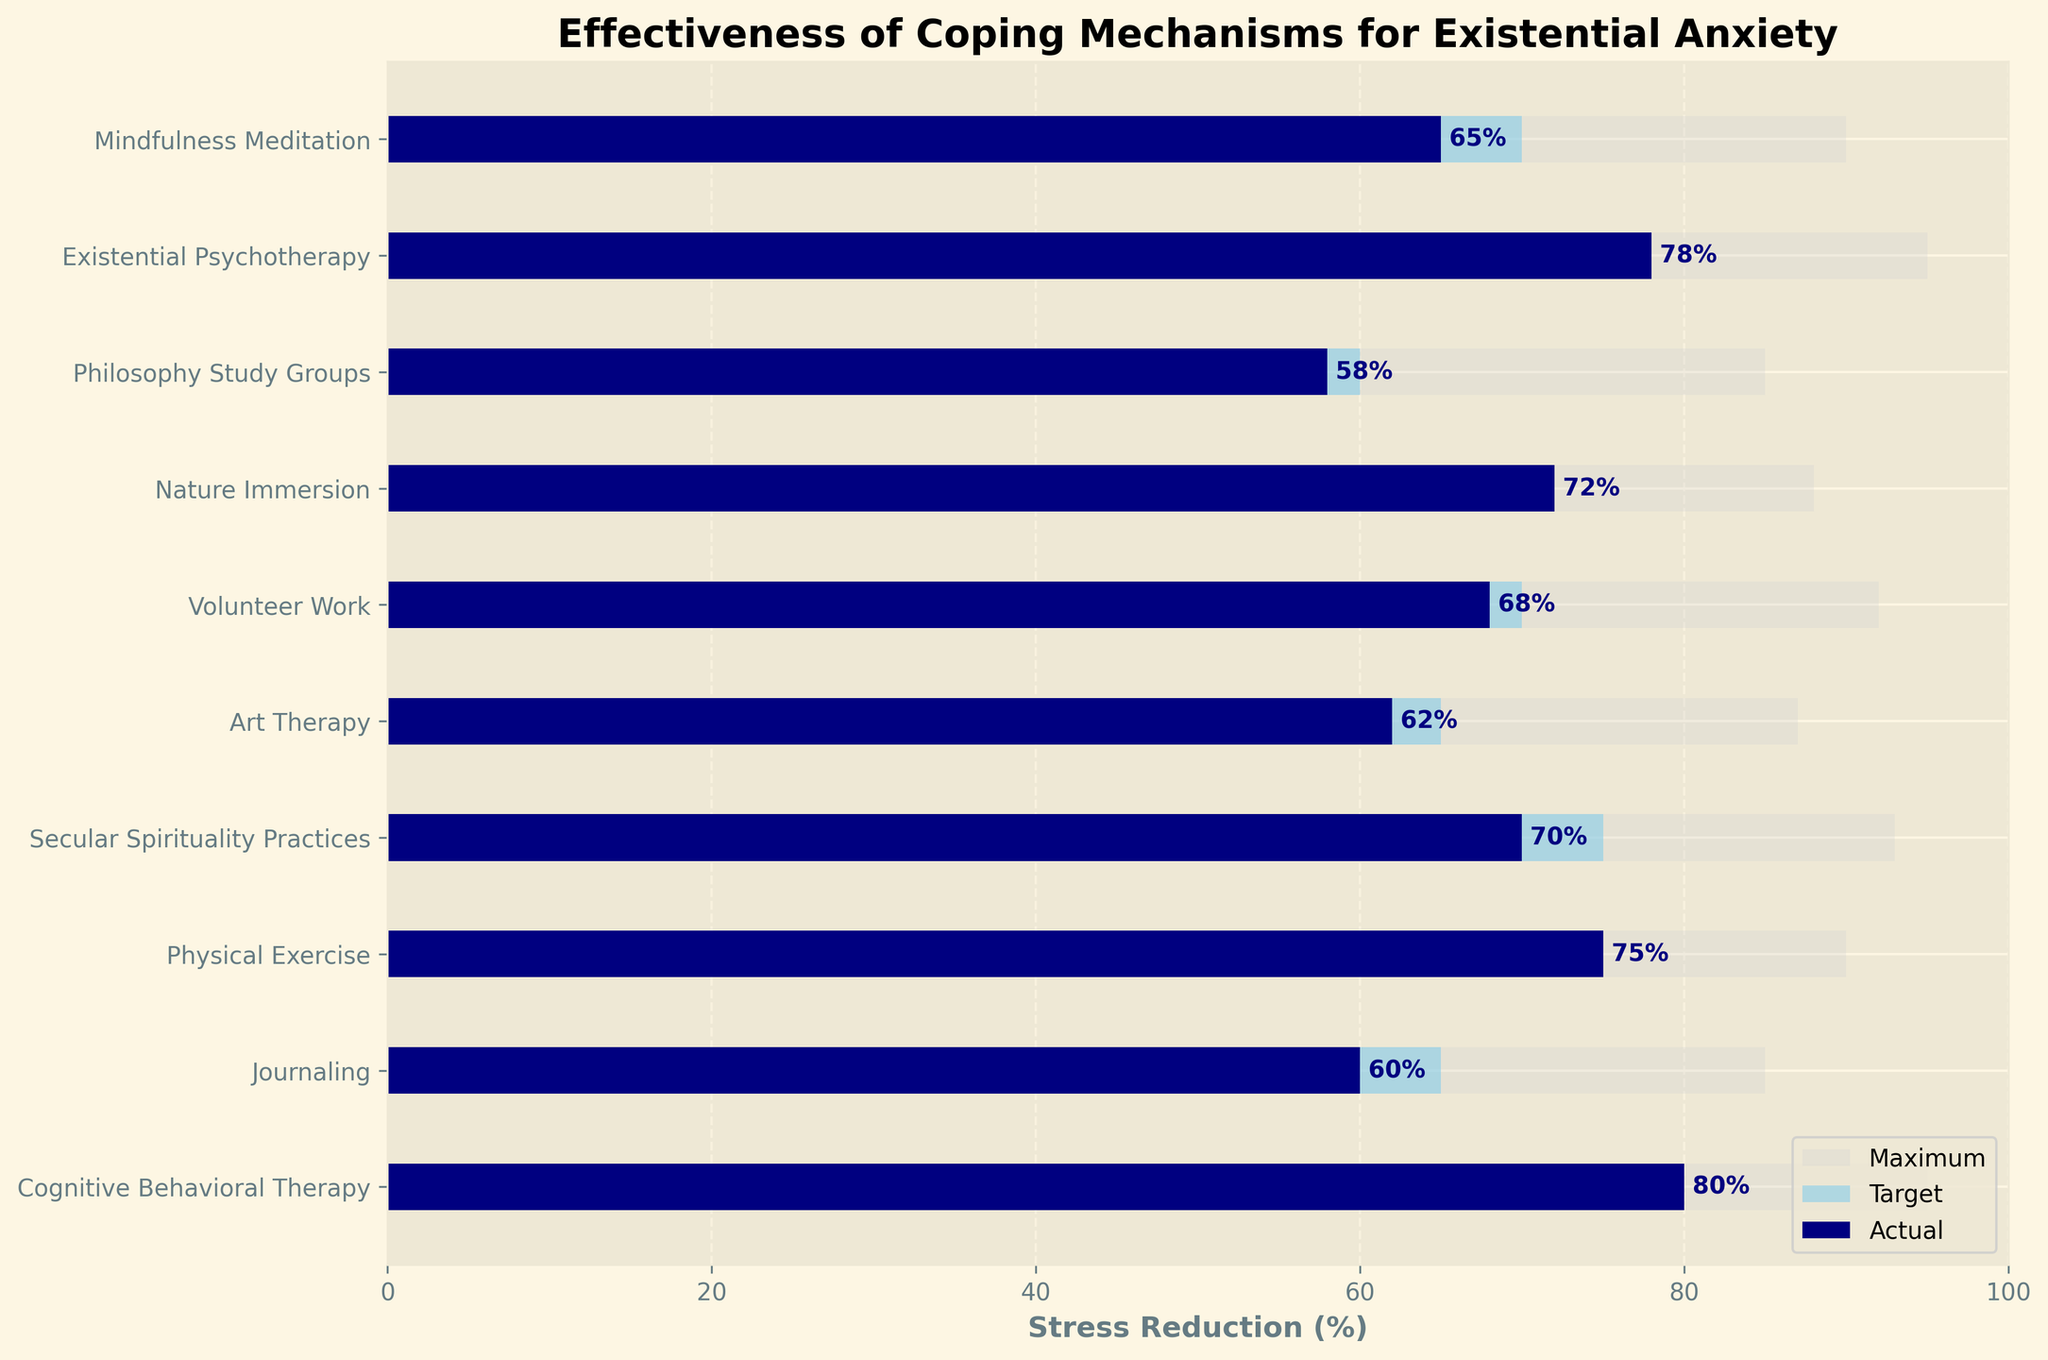What is the actual stress reduction percentage for Cognitive Behavioral Therapy? Locate the bar labeled "Cognitive Behavioral Therapy" and find the value shown within the dark blue bar representing the actual stress reduction percentage.
Answer: 80% Which coping mechanism has the highest actual stress reduction percentage? Compare the values within the dark blue bars to find the coping mechanism with the highest value.
Answer: Cognitive Behavioral Therapy How much is the difference between the target and actual stress reductions for Volunteer Work? Subtract the actual stress reduction percentage from the target stress reduction percentage for Volunteer Work. Target is 70%, and actual is 68%, so the difference is 70 - 68 = 2%.
Answer: 2% What is the total number of coping mechanisms shown in the figure? Count the total number of different coping mechanisms listed on the y-axis.
Answer: 10 Which coping mechanism exceeded its target stress reduction percentage by the largest margin? Calculate the difference between actual and target stress reductions for each coping mechanism, and find the maximum value. Existential Psychotherapy has the largest difference: 78% - 75% = 3%.
Answer: Existential Psychotherapy What is the target stress reduction percentage for Philosophy Study Groups? Locate the bar labeled "Philosophy Study Groups" and identify the value shown within the light blue bar representing the target stress reduction percentage.
Answer: 60% Amongst the mechanisms listed, which has the smallest difference between actual and maximum stress reduction? Compute the difference between actual and maximum stress reductions for each mechanism and identify the smallest value. Philosophy Study Groups have the smallest difference: 85% - 58% = 27%.
Answer: Philosophy Study Groups Which two coping mechanisms have the same target stress reduction percentage? Look at the target (light blue) bars and identify any two mechanisms with matching values. Volunteer Work and Mindfulness Meditation both have a target of 70%.
Answer: Volunteer Work, Mindfulness Meditation What’s the average actual stress reduction percentage for all the coping mechanisms? Sum the actual stress reduction percentages for all mechanisms and divide by the number of mechanisms. (65 + 78 + 58 + 72 + 68 + 62 + 70 + 75 + 60 + 80)/10 = 68.8%.
Answer: 68.8% For Nature Immersion, how close is the actual stress reduction percentage to the maximum stress reduction percentage? Calculate the difference between actual (72%) and maximum (88%) stress reductions for Nature Immersion. 88% - 72% = 16%.
Answer: 16% 